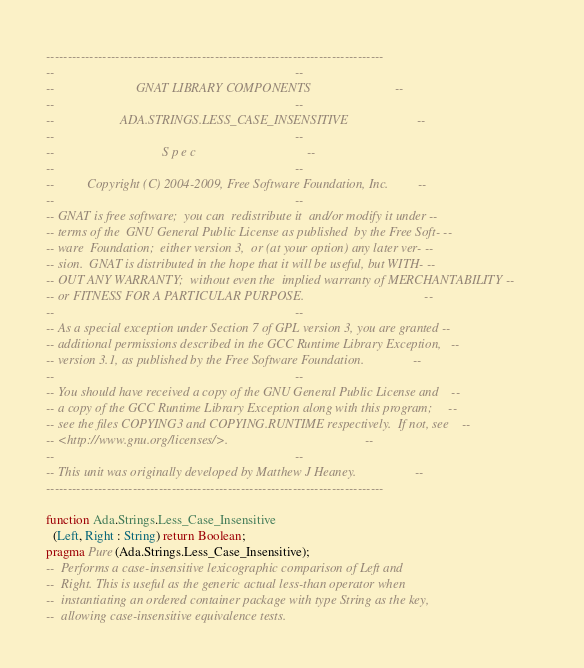<code> <loc_0><loc_0><loc_500><loc_500><_Ada_>------------------------------------------------------------------------------
--                                                                          --
--                         GNAT LIBRARY COMPONENTS                          --
--                                                                          --
--                    ADA.STRINGS.LESS_CASE_INSENSITIVE                     --
--                                                                          --
--                                 S p e c                                  --
--                                                                          --
--          Copyright (C) 2004-2009, Free Software Foundation, Inc.         --
--                                                                          --
-- GNAT is free software;  you can  redistribute it  and/or modify it under --
-- terms of the  GNU General Public License as published  by the Free Soft- --
-- ware  Foundation;  either version 3,  or (at your option) any later ver- --
-- sion.  GNAT is distributed in the hope that it will be useful, but WITH- --
-- OUT ANY WARRANTY;  without even the  implied warranty of MERCHANTABILITY --
-- or FITNESS FOR A PARTICULAR PURPOSE.                                     --
--                                                                          --
-- As a special exception under Section 7 of GPL version 3, you are granted --
-- additional permissions described in the GCC Runtime Library Exception,   --
-- version 3.1, as published by the Free Software Foundation.               --
--                                                                          --
-- You should have received a copy of the GNU General Public License and    --
-- a copy of the GCC Runtime Library Exception along with this program;     --
-- see the files COPYING3 and COPYING.RUNTIME respectively.  If not, see    --
-- <http://www.gnu.org/licenses/>.                                          --
--                                                                          --
-- This unit was originally developed by Matthew J Heaney.                  --
------------------------------------------------------------------------------

function Ada.Strings.Less_Case_Insensitive
  (Left, Right : String) return Boolean;
pragma Pure (Ada.Strings.Less_Case_Insensitive);
--  Performs a case-insensitive lexicographic comparison of Left and
--  Right. This is useful as the generic actual less-than operator when
--  instantiating an ordered container package with type String as the key,
--  allowing case-insensitive equivalence tests.
</code> 